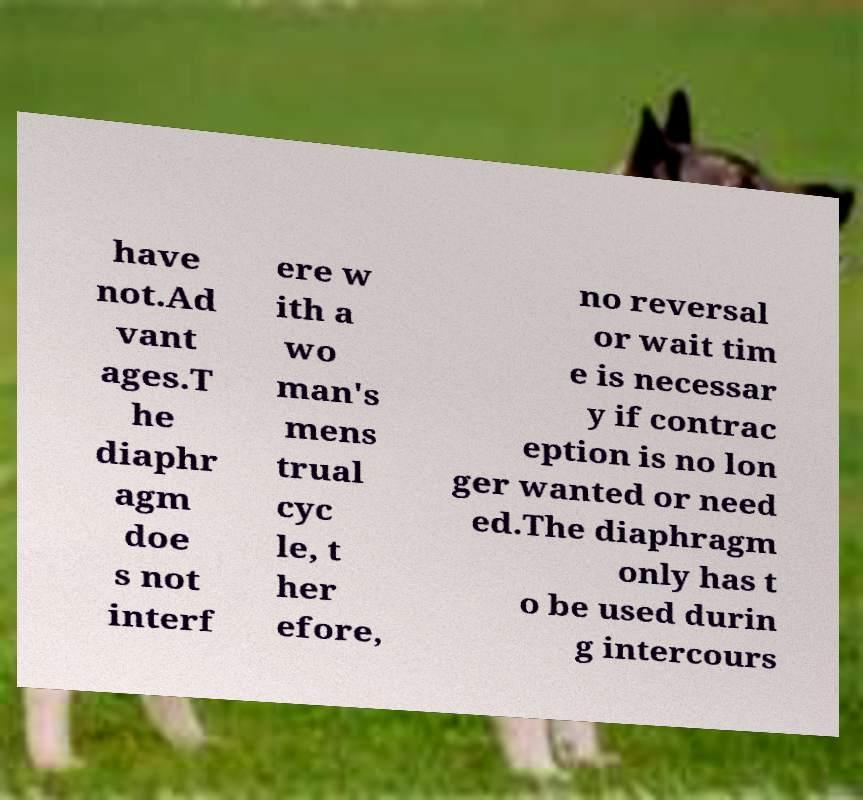I need the written content from this picture converted into text. Can you do that? have not.Ad vant ages.T he diaphr agm doe s not interf ere w ith a wo man's mens trual cyc le, t her efore, no reversal or wait tim e is necessar y if contrac eption is no lon ger wanted or need ed.The diaphragm only has t o be used durin g intercours 